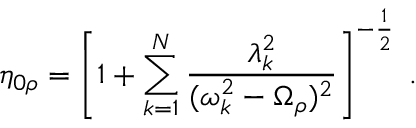Convert formula to latex. <formula><loc_0><loc_0><loc_500><loc_500>\eta _ { 0 \rho } = \left [ 1 + \sum _ { k = 1 } ^ { N } \frac { \lambda _ { k } ^ { 2 } } { ( \omega _ { k } ^ { 2 } - \Omega _ { \rho } ) ^ { 2 } } \right ] ^ { - \frac { 1 } { 2 } } \, .</formula> 